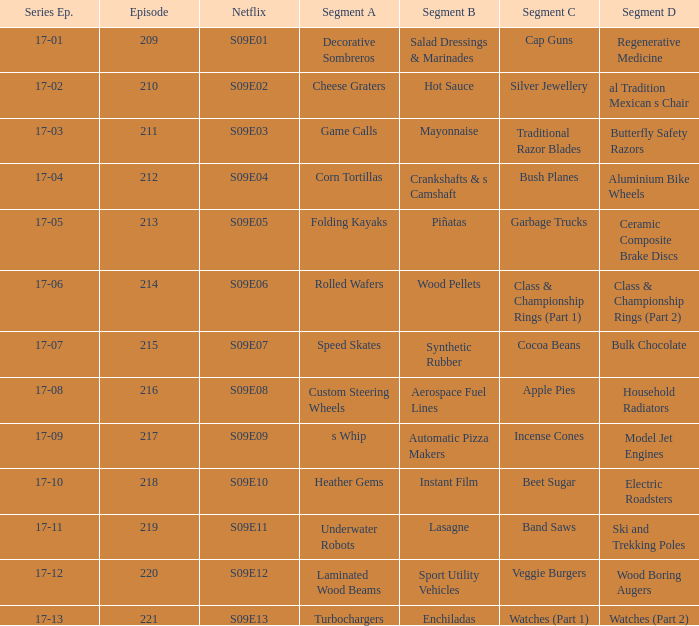Segment B of aerospace fuel lines is what netflix episode? S09E08. 